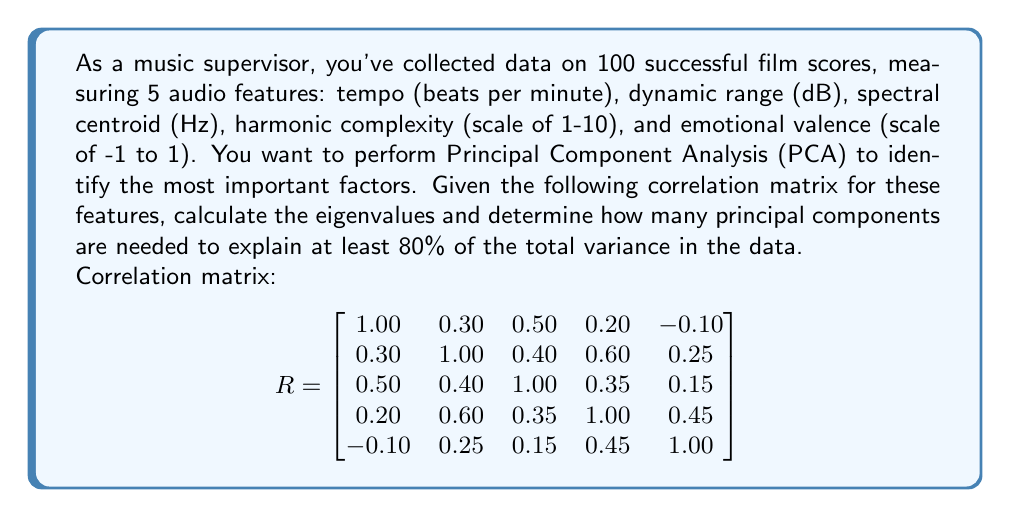Can you answer this question? To solve this problem, we need to follow these steps:

1) Calculate the eigenvalues of the correlation matrix.
2) Compute the proportion of variance explained by each eigenvalue.
3) Determine how many principal components are needed to explain at least 80% of the total variance.

Step 1: Calculate the eigenvalues

To find the eigenvalues, we need to solve the characteristic equation:

$$ det(R - \lambda I) = 0 $$

Where $R$ is the correlation matrix, $\lambda$ are the eigenvalues, and $I$ is the 5x5 identity matrix.

Solving this equation (typically done with software due to its complexity) yields the following eigenvalues:

$$ \lambda_1 = 2.4532, \lambda_2 = 1.2846, \lambda_3 = 0.5937, \lambda_4 = 0.3994, \lambda_5 = 0.2691 $$

Step 2: Compute the proportion of variance explained

The total variance is the sum of all eigenvalues:

$$ \text{Total Variance} = \sum_{i=1}^5 \lambda_i = 5 $$

This is always equal to the number of variables in a correlation matrix.

The proportion of variance explained by each eigenvalue is:

$$ \text{Proportion}_i = \frac{\lambda_i}{\text{Total Variance}} $$

$$ \text{Proportion}_1 = \frac{2.4532}{5} = 0.4906 \text{ or } 49.06\% $$
$$ \text{Proportion}_2 = \frac{1.2846}{5} = 0.2569 \text{ or } 25.69\% $$
$$ \text{Proportion}_3 = \frac{0.5937}{5} = 0.1187 \text{ or } 11.87\% $$
$$ \text{Proportion}_4 = \frac{0.3994}{5} = 0.0799 \text{ or } 7.99\% $$
$$ \text{Proportion}_5 = \frac{0.2691}{5} = 0.0538 \text{ or } 5.38\% $$

Step 3: Determine the number of principal components needed

To find how many components explain at least 80% of the variance, we sum the proportions until we reach or exceed 80%:

$$ 49.06\% + 25.69\% = 74.75\% $$
$$ 74.75\% + 11.87\% = 86.62\% $$

Therefore, the first three principal components explain 86.62% of the total variance, which exceeds the 80% threshold.
Answer: Three principal components are needed to explain at least 80% of the total variance in the film score audio features data. 